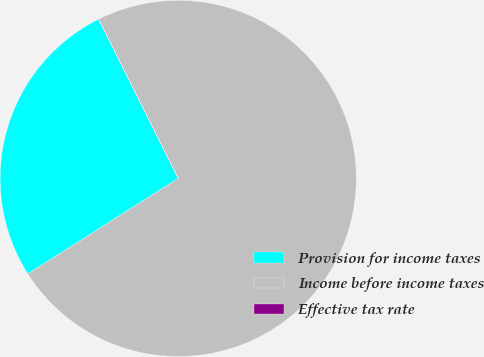Convert chart to OTSL. <chart><loc_0><loc_0><loc_500><loc_500><pie_chart><fcel>Provision for income taxes<fcel>Income before income taxes<fcel>Effective tax rate<nl><fcel>26.62%<fcel>73.38%<fcel>0.0%<nl></chart> 